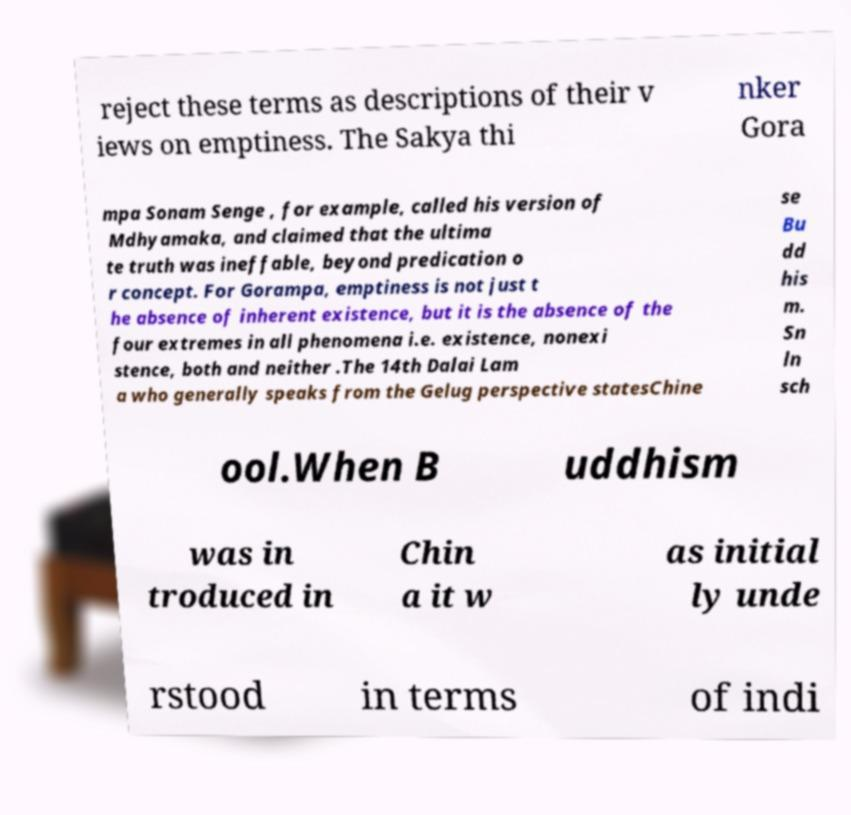Can you accurately transcribe the text from the provided image for me? reject these terms as descriptions of their v iews on emptiness. The Sakya thi nker Gora mpa Sonam Senge , for example, called his version of Mdhyamaka, and claimed that the ultima te truth was ineffable, beyond predication o r concept. For Gorampa, emptiness is not just t he absence of inherent existence, but it is the absence of the four extremes in all phenomena i.e. existence, nonexi stence, both and neither .The 14th Dalai Lam a who generally speaks from the Gelug perspective statesChine se Bu dd his m. Sn ln sch ool.When B uddhism was in troduced in Chin a it w as initial ly unde rstood in terms of indi 